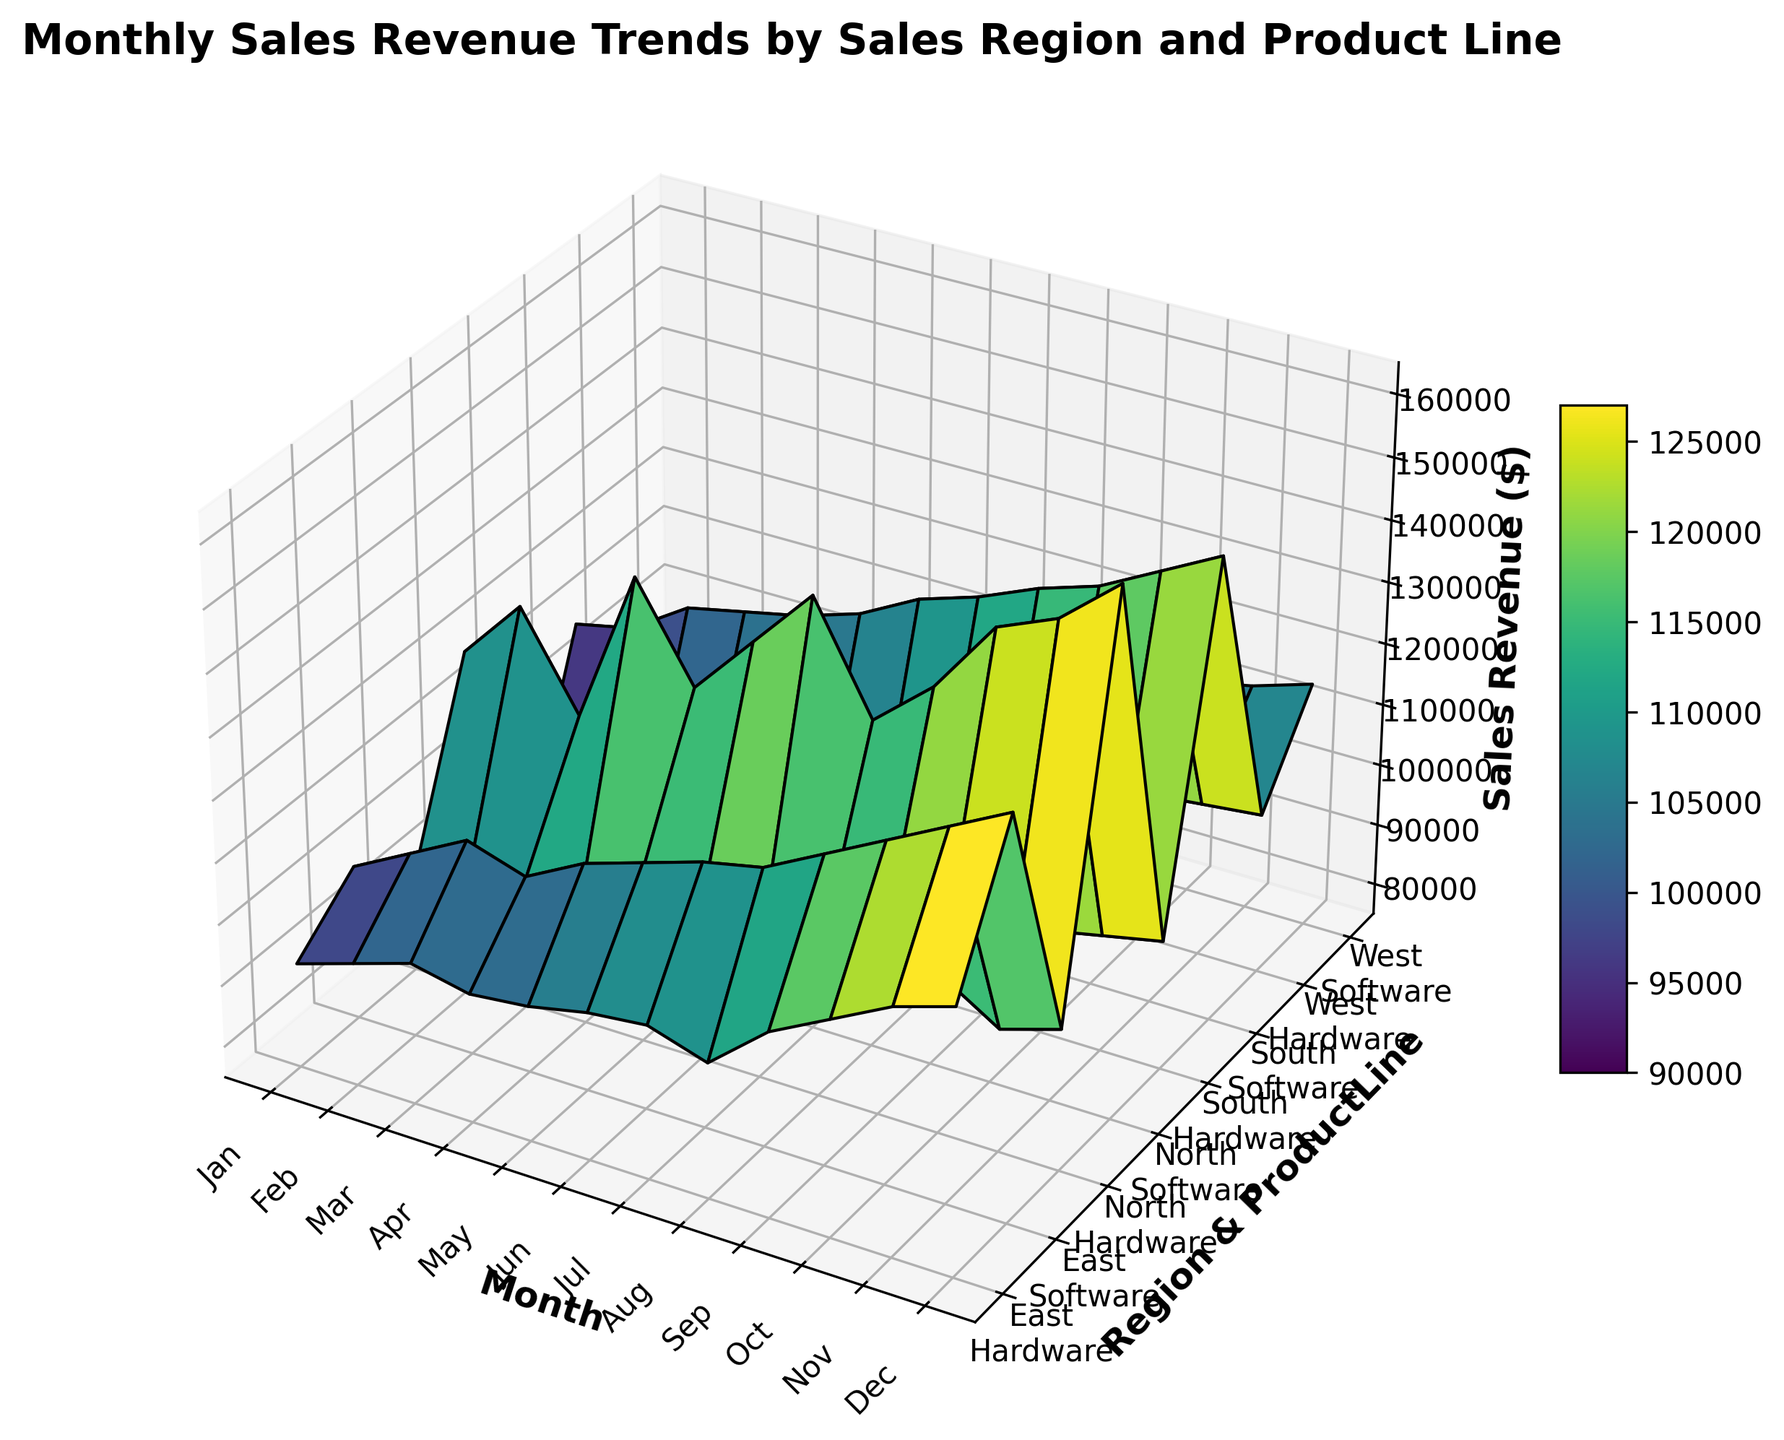Which region has the highest peak in sales revenue for software? The highest peak in sales revenue for software can be observed by comparing the highest points on the surface corresponding to the software product line for each region. The North region has the highest peak at around $160,000, which is higher than the peaks in other regions.
Answer: North Which region and product line combination had the lowest sales revenue? By examining the lowest points on the surface across all region and product line combinations, we see that the lowest sales revenue is for the South region's hardware product line, with values around $80,000.
Answer: South Hardware What is the average sales revenue for the East region's hardware product line over all months? To find the average sales revenue for the East region's hardware product line, sum the sales revenue for each month and divide by the number of months: (92000 + 95000 + 98000 + 96000 + 97000 + 99000 + 100000 + 97000 + 105000 + 110000 + 115000 + 118000) / 12 = 101,000.
Answer: 101,000 Compare the sales trends between North and South regions for the software product line. Which region shows a more consistent growth pattern? By observing the surface trends for both the North and South regions' software product lines, the South region shows a more consistent growth pattern with a steady increase throughout the months. In contrast, the North region shows more fluctuations.
Answer: South What is the difference in peak sales revenue between the North and West regions for the software product line? The peak sales revenue for the North region's software product line is $160,000, while for the West region it is $115,000. The difference is 160,000 - 115,000 = $45,000.
Answer: $45,000 Which month shows the highest overall sales revenue for all regions combined? By examining the peaks in the surface plot for each month across all regions and product lines, December shows the highest overall sales revenue, especially for software products.
Answer: December What is the total sales revenue for all product lines in the South region in June? Total sales revenue for the South region in June = South Software (125000) + South Hardware (85000) = 125000 + 85000 = 210000.
Answer: 210,000 How do the revenue trends for hardware products compare between the North and East regions? The trends for hardware products in the North and East regions can be compared by examining their respective surfaces. The East region shows a more consistent increase in revenue with a peak at $118,000, while the North region has more fluctuations and a lower peak at $101,000.
Answer: East region has more consistent increase Which product line in the West region had a higher sales revenue in November? By looking solely at the sales revenue in November for the West region, the sales revenue for Software (112000) is higher than Hardware (100000).
Answer: Software What is the year-end (December) sales revenue difference between the North region's hardware and software product lines? The December sales revenue for the North region's hardware product line is $98,000, and for the software product line, it is $160,000. The difference is 160,000 - 98,000 = $62,000.
Answer: $62,000 